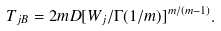<formula> <loc_0><loc_0><loc_500><loc_500>T _ { j B } = 2 m D [ { W _ { j } / \Gamma ( 1 / m ) } ] ^ { m / ( m - 1 ) } .</formula> 